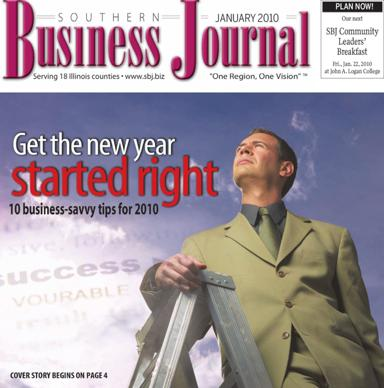What event is being advertised in the image? The image is promoting the SBJ Community Leaders' Breakfast, an important local networking event aimed at fostering community ties and leadership development. Set to take place in January 2010, it gathers prominent figures and aspiring leaders for insightful discussions and networking. This event will be held at the Logan Center, adding a touch of elegance to the occasion. 